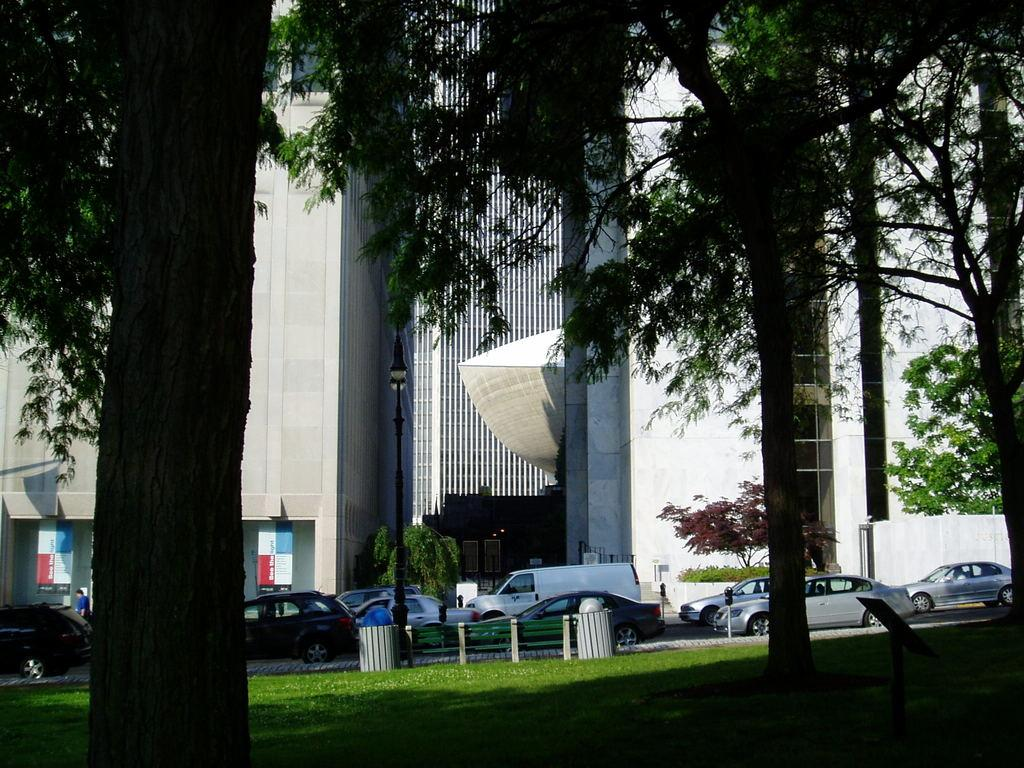What can be seen parked on the road in the image? There is a group of vehicles parked on the road in the image. What is the tall, vertical object in the image? There is a light pole in the image. How many trash bins are visible in the image? There are two trash bins in the image. What can be seen in the background of the image? There is a group of trees and buildings visible in the background of the image. What type of bone can be seen in the image? There is no bone present in the image. What route are the vehicles taking in the image? The image does not show the vehicles in motion, so it is not possible to determine the route they are taking. 